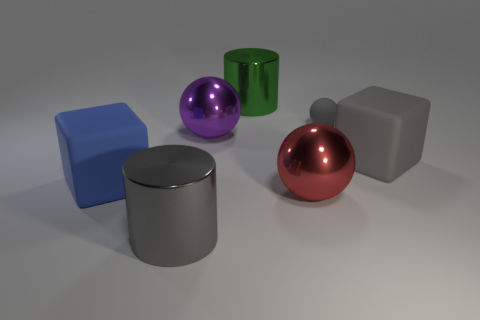What textures can be observed on the surfaces of the objects in the image? The objects in the image display a variety of textures. The two cubes exhibit a flat, matte finish. The large and small spheres, as well as the cylinder in the center, have reflective, shiny surfaces, while the remaining cylinder has a slightly reflective but mostly matte texture. 